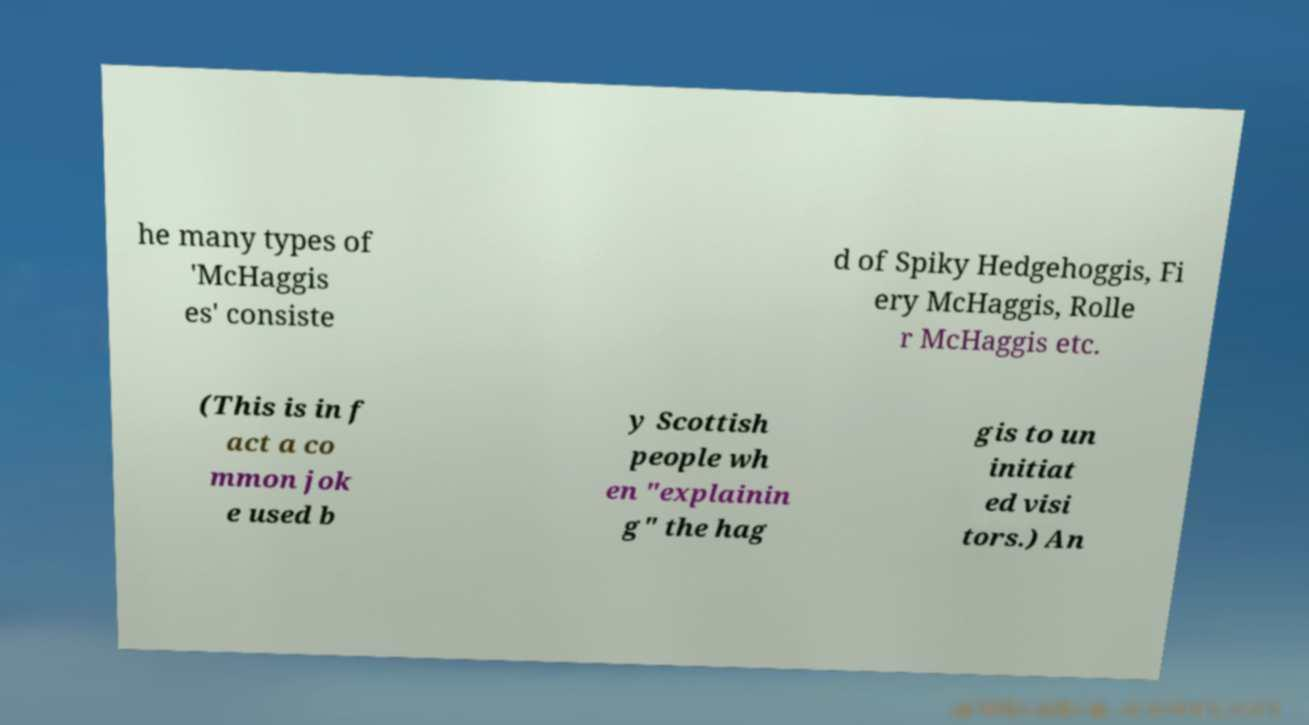Could you assist in decoding the text presented in this image and type it out clearly? he many types of 'McHaggis es' consiste d of Spiky Hedgehoggis, Fi ery McHaggis, Rolle r McHaggis etc. (This is in f act a co mmon jok e used b y Scottish people wh en "explainin g" the hag gis to un initiat ed visi tors.) An 